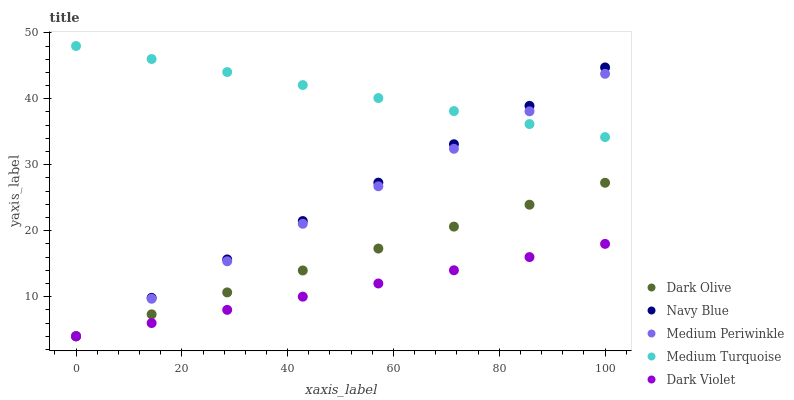Does Dark Violet have the minimum area under the curve?
Answer yes or no. Yes. Does Medium Turquoise have the maximum area under the curve?
Answer yes or no. Yes. Does Dark Olive have the minimum area under the curve?
Answer yes or no. No. Does Dark Olive have the maximum area under the curve?
Answer yes or no. No. Is Dark Violet the smoothest?
Answer yes or no. Yes. Is Medium Turquoise the roughest?
Answer yes or no. Yes. Is Dark Olive the smoothest?
Answer yes or no. No. Is Dark Olive the roughest?
Answer yes or no. No. Does Navy Blue have the lowest value?
Answer yes or no. Yes. Does Medium Turquoise have the lowest value?
Answer yes or no. No. Does Medium Turquoise have the highest value?
Answer yes or no. Yes. Does Dark Olive have the highest value?
Answer yes or no. No. Is Dark Violet less than Medium Turquoise?
Answer yes or no. Yes. Is Medium Turquoise greater than Dark Violet?
Answer yes or no. Yes. Does Medium Turquoise intersect Navy Blue?
Answer yes or no. Yes. Is Medium Turquoise less than Navy Blue?
Answer yes or no. No. Is Medium Turquoise greater than Navy Blue?
Answer yes or no. No. Does Dark Violet intersect Medium Turquoise?
Answer yes or no. No. 